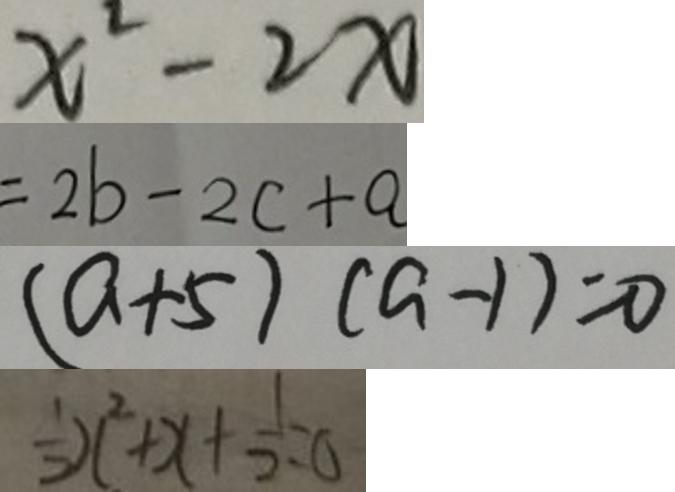Convert formula to latex. <formula><loc_0><loc_0><loc_500><loc_500>x ^ { 2 } - 2 x 
 = 2 b - 2 c + a 
 ( a + 5 ) ( a - 1 ) = 0 
 \frac { 1 } { 2 } x ^ { 2 } + x + \frac { 1 } { 2 } = 0</formula> 